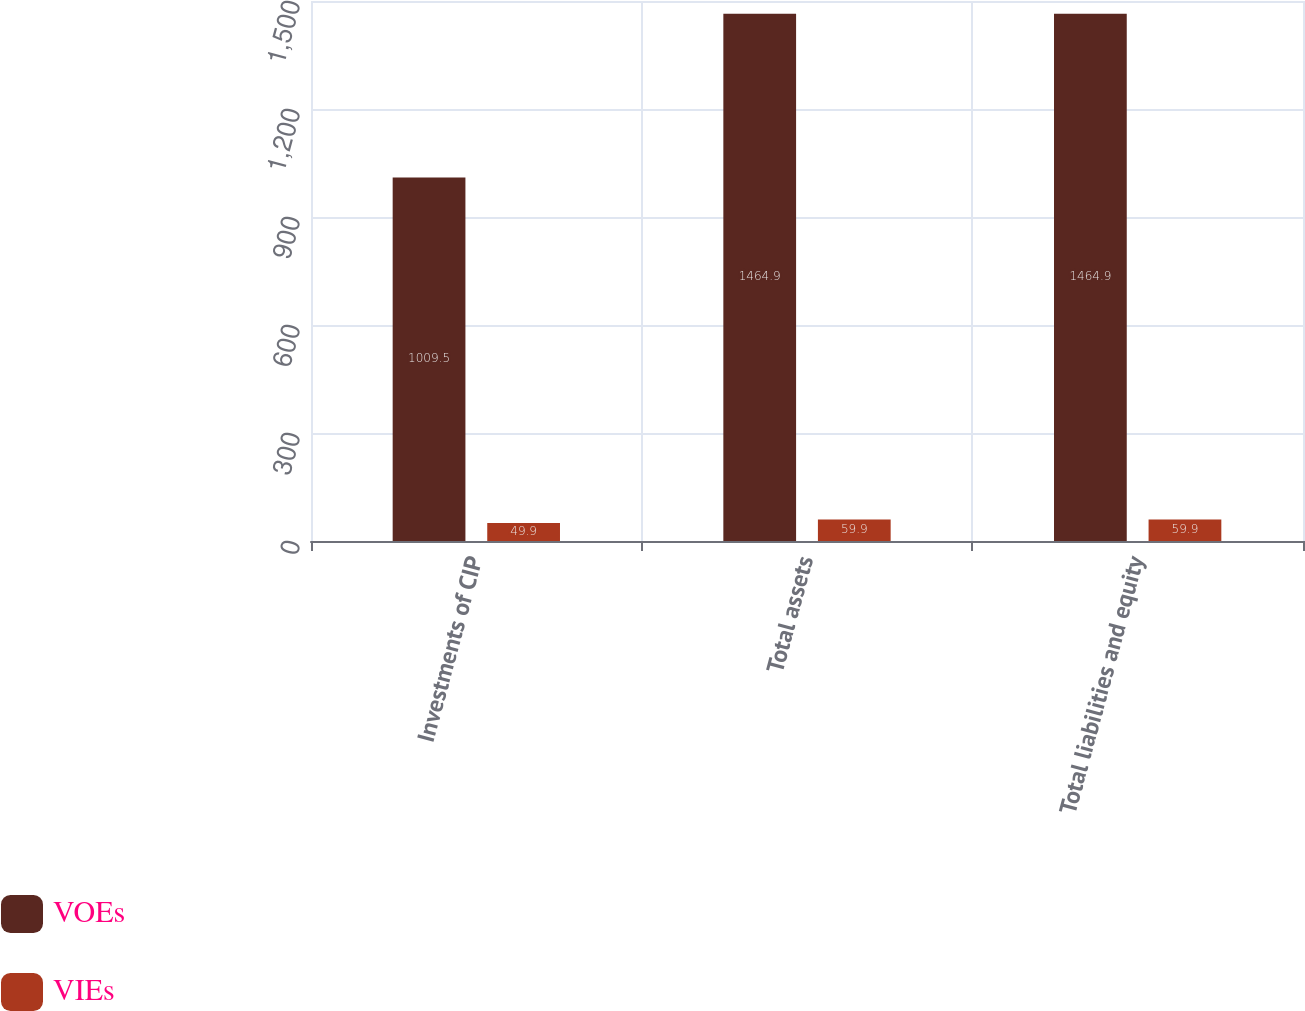Convert chart to OTSL. <chart><loc_0><loc_0><loc_500><loc_500><stacked_bar_chart><ecel><fcel>Investments of CIP<fcel>Total assets<fcel>Total liabilities and equity<nl><fcel>VOEs<fcel>1009.5<fcel>1464.9<fcel>1464.9<nl><fcel>VIEs<fcel>49.9<fcel>59.9<fcel>59.9<nl></chart> 